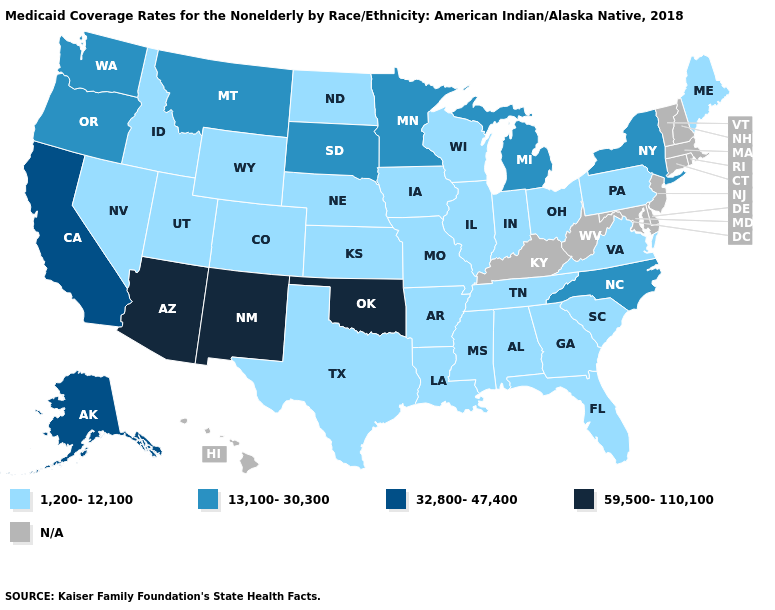Among the states that border Utah , does Wyoming have the lowest value?
Concise answer only. Yes. Does Arizona have the highest value in the USA?
Give a very brief answer. Yes. Does Arizona have the highest value in the West?
Answer briefly. Yes. Name the states that have a value in the range 59,500-110,100?
Concise answer only. Arizona, New Mexico, Oklahoma. What is the lowest value in the USA?
Give a very brief answer. 1,200-12,100. Which states have the lowest value in the USA?
Keep it brief. Alabama, Arkansas, Colorado, Florida, Georgia, Idaho, Illinois, Indiana, Iowa, Kansas, Louisiana, Maine, Mississippi, Missouri, Nebraska, Nevada, North Dakota, Ohio, Pennsylvania, South Carolina, Tennessee, Texas, Utah, Virginia, Wisconsin, Wyoming. What is the value of Washington?
Short answer required. 13,100-30,300. Name the states that have a value in the range 13,100-30,300?
Be succinct. Michigan, Minnesota, Montana, New York, North Carolina, Oregon, South Dakota, Washington. Does Minnesota have the lowest value in the USA?
Give a very brief answer. No. Does Arizona have the lowest value in the USA?
Concise answer only. No. What is the lowest value in states that border California?
Give a very brief answer. 1,200-12,100. Name the states that have a value in the range 1,200-12,100?
Answer briefly. Alabama, Arkansas, Colorado, Florida, Georgia, Idaho, Illinois, Indiana, Iowa, Kansas, Louisiana, Maine, Mississippi, Missouri, Nebraska, Nevada, North Dakota, Ohio, Pennsylvania, South Carolina, Tennessee, Texas, Utah, Virginia, Wisconsin, Wyoming. 